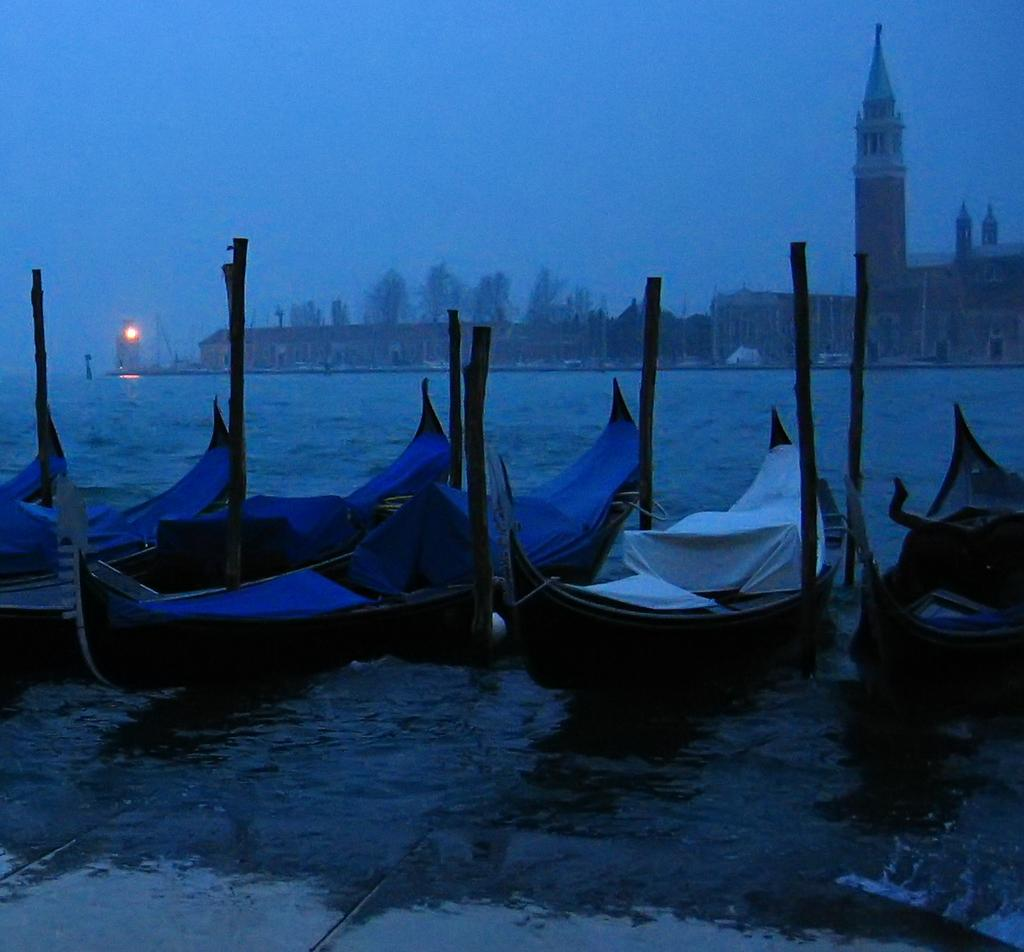What is on the water in the image? There are boats on the water in the image. What type of structures can be seen in the image? There are buildings visible in the image. What type of vegetation is present in the image? Trees are present in the image. What is the source of illumination in the image? There is light in the image. What else can be found in the image besides the boats, buildings, and trees? There are objects in the image. What is visible in the background of the image? The sky is visible in the background of the image. How does the vessel rub against the star in the image? There is no vessel or star present in the image; it features boats on the water, buildings, trees, light, objects, and a visible sky in the background. 